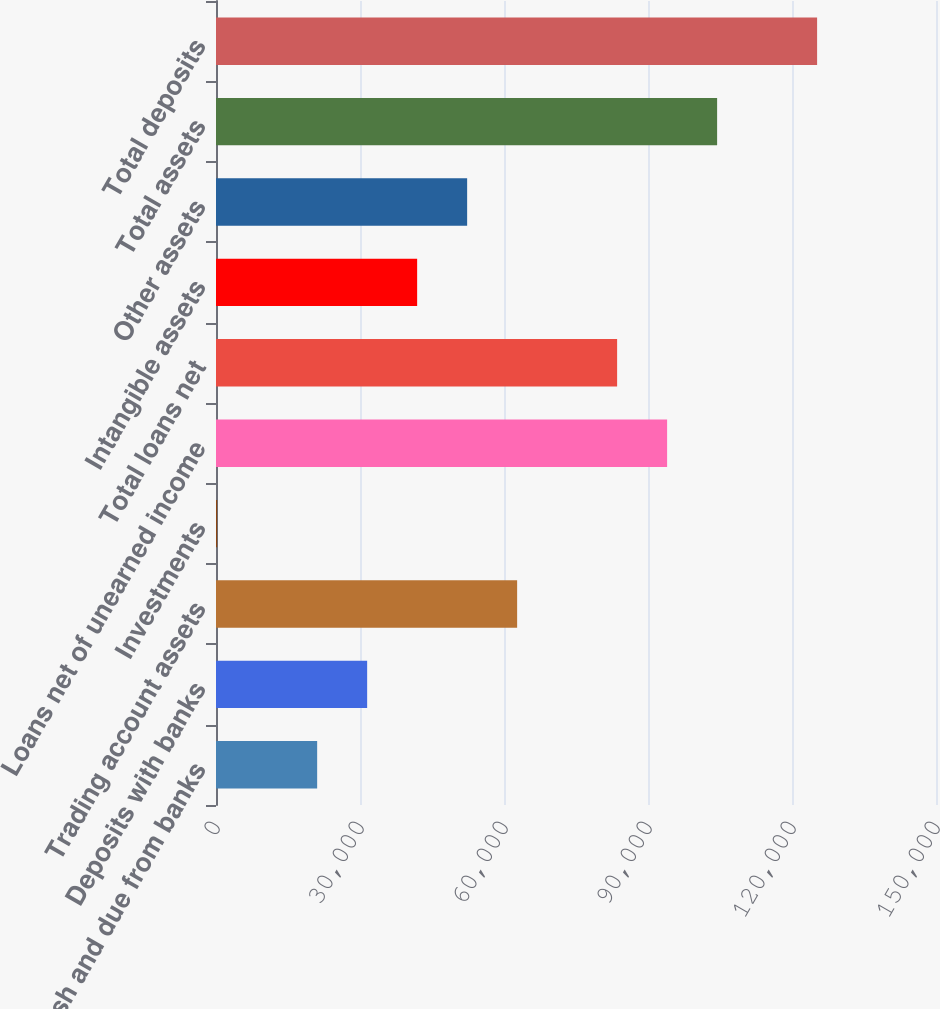Convert chart to OTSL. <chart><loc_0><loc_0><loc_500><loc_500><bar_chart><fcel>Cash and due from banks<fcel>Deposits with banks<fcel>Trading account assets<fcel>Investments<fcel>Loans net of unearned income<fcel>Total loans net<fcel>Intangible assets<fcel>Other assets<fcel>Total assets<fcel>Total deposits<nl><fcel>21074.8<fcel>31490.2<fcel>62736.4<fcel>244<fcel>93982.6<fcel>83567.2<fcel>41905.6<fcel>52321<fcel>104398<fcel>125229<nl></chart> 